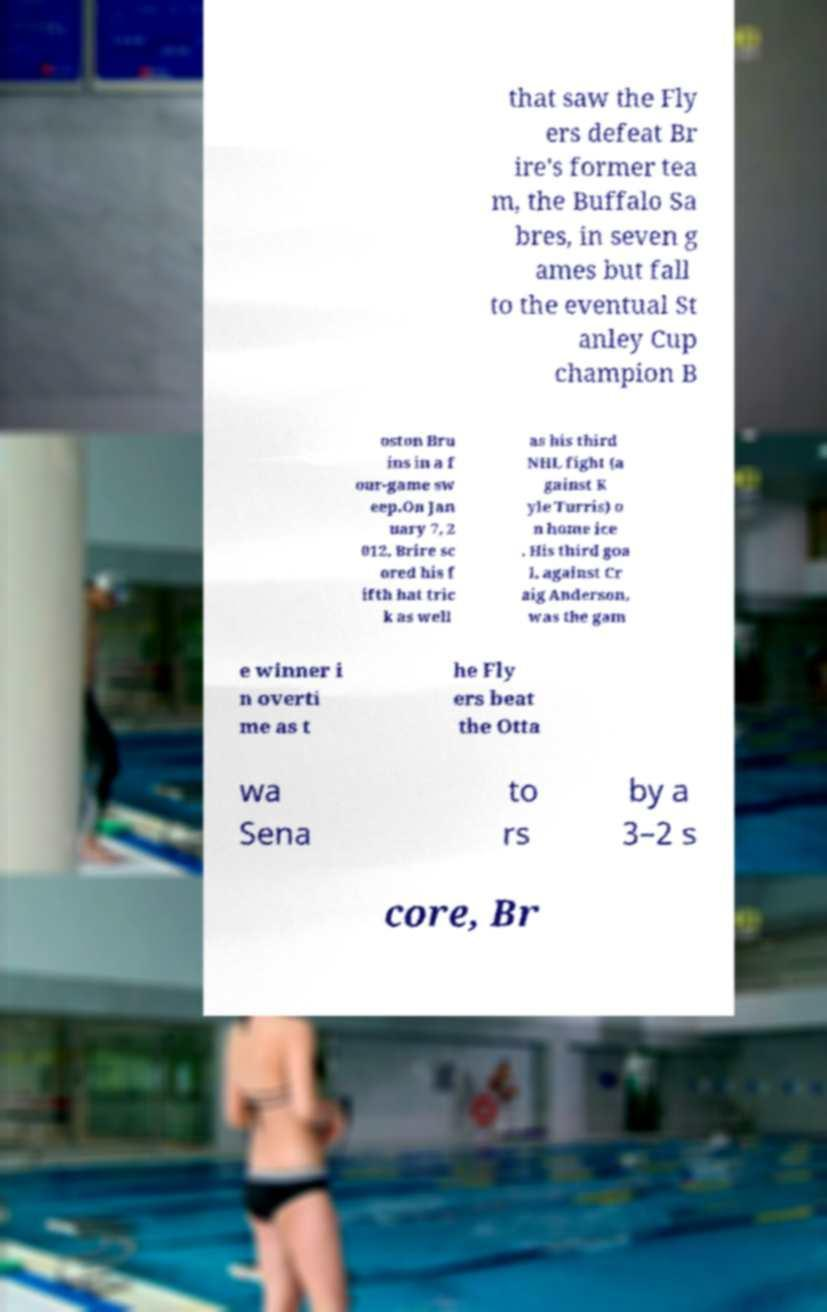What messages or text are displayed in this image? I need them in a readable, typed format. that saw the Fly ers defeat Br ire's former tea m, the Buffalo Sa bres, in seven g ames but fall to the eventual St anley Cup champion B oston Bru ins in a f our-game sw eep.On Jan uary 7, 2 012, Brire sc ored his f ifth hat tric k as well as his third NHL fight (a gainst K yle Turris) o n home ice . His third goa l, against Cr aig Anderson, was the gam e winner i n overti me as t he Fly ers beat the Otta wa Sena to rs by a 3–2 s core, Br 